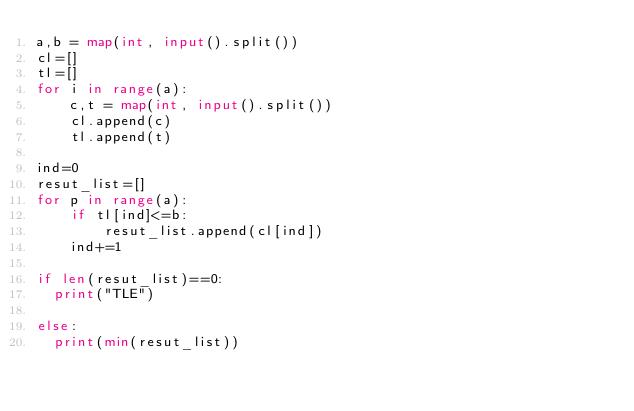Convert code to text. <code><loc_0><loc_0><loc_500><loc_500><_Python_>a,b = map(int, input().split())
cl=[]
tl=[]
for i in range(a):
    c,t = map(int, input().split())
    cl.append(c)
    tl.append(t)
    
ind=0
resut_list=[]
for p in range(a):
    if tl[ind]<=b:
        resut_list.append(cl[ind])   
    ind+=1
    
if len(resut_list)==0:
  print("TLE")  

else:
  print(min(resut_list))
</code> 